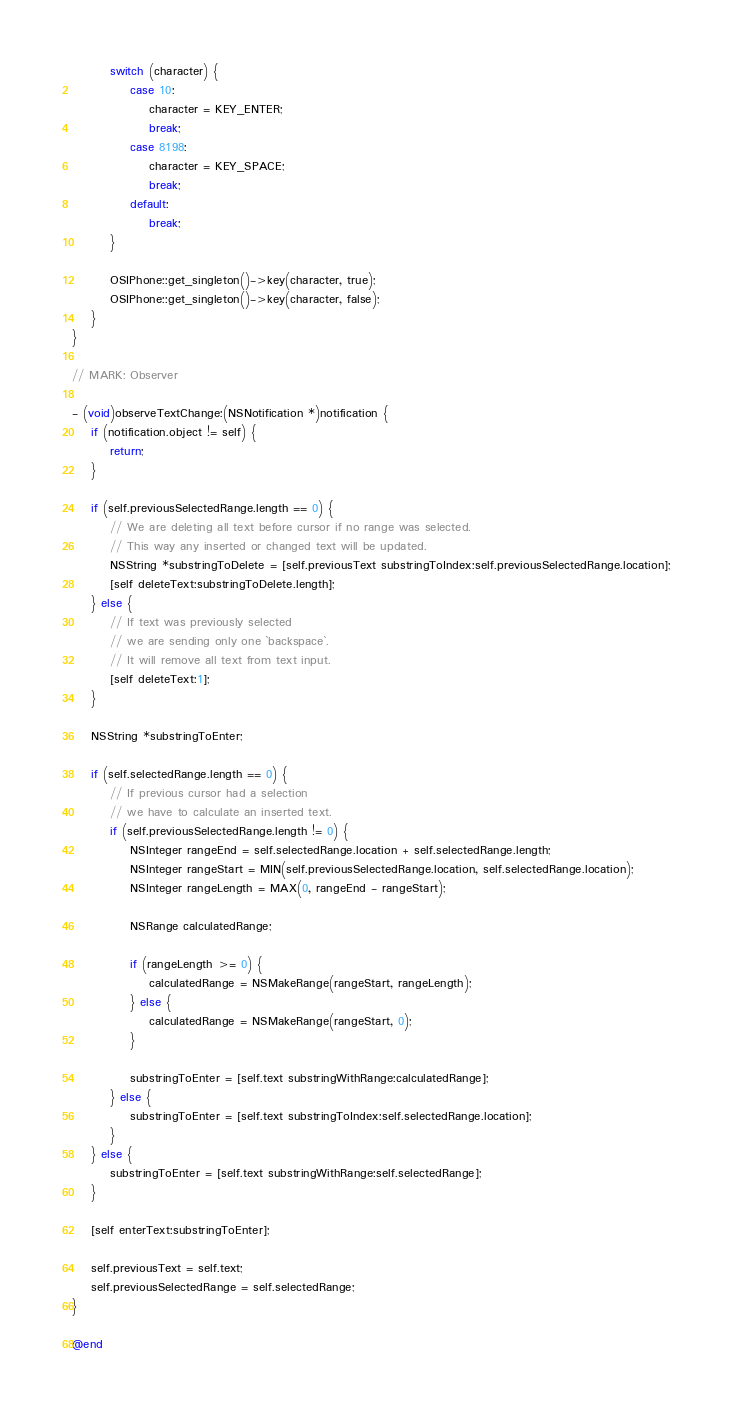Convert code to text. <code><loc_0><loc_0><loc_500><loc_500><_ObjectiveC_>
		switch (character) {
			case 10:
				character = KEY_ENTER;
				break;
			case 8198:
				character = KEY_SPACE;
				break;
			default:
				break;
		}

		OSIPhone::get_singleton()->key(character, true);
		OSIPhone::get_singleton()->key(character, false);
	}
}

// MARK: Observer

- (void)observeTextChange:(NSNotification *)notification {
	if (notification.object != self) {
		return;
	}

	if (self.previousSelectedRange.length == 0) {
		// We are deleting all text before cursor if no range was selected.
		// This way any inserted or changed text will be updated.
		NSString *substringToDelete = [self.previousText substringToIndex:self.previousSelectedRange.location];
		[self deleteText:substringToDelete.length];
	} else {
		// If text was previously selected
		// we are sending only one `backspace`.
		// It will remove all text from text input.
		[self deleteText:1];
	}

	NSString *substringToEnter;

	if (self.selectedRange.length == 0) {
		// If previous cursor had a selection
		// we have to calculate an inserted text.
		if (self.previousSelectedRange.length != 0) {
			NSInteger rangeEnd = self.selectedRange.location + self.selectedRange.length;
			NSInteger rangeStart = MIN(self.previousSelectedRange.location, self.selectedRange.location);
			NSInteger rangeLength = MAX(0, rangeEnd - rangeStart);

			NSRange calculatedRange;

			if (rangeLength >= 0) {
				calculatedRange = NSMakeRange(rangeStart, rangeLength);
			} else {
				calculatedRange = NSMakeRange(rangeStart, 0);
			}

			substringToEnter = [self.text substringWithRange:calculatedRange];
		} else {
			substringToEnter = [self.text substringToIndex:self.selectedRange.location];
		}
	} else {
		substringToEnter = [self.text substringWithRange:self.selectedRange];
	}

	[self enterText:substringToEnter];

	self.previousText = self.text;
	self.previousSelectedRange = self.selectedRange;
}

@end
</code> 